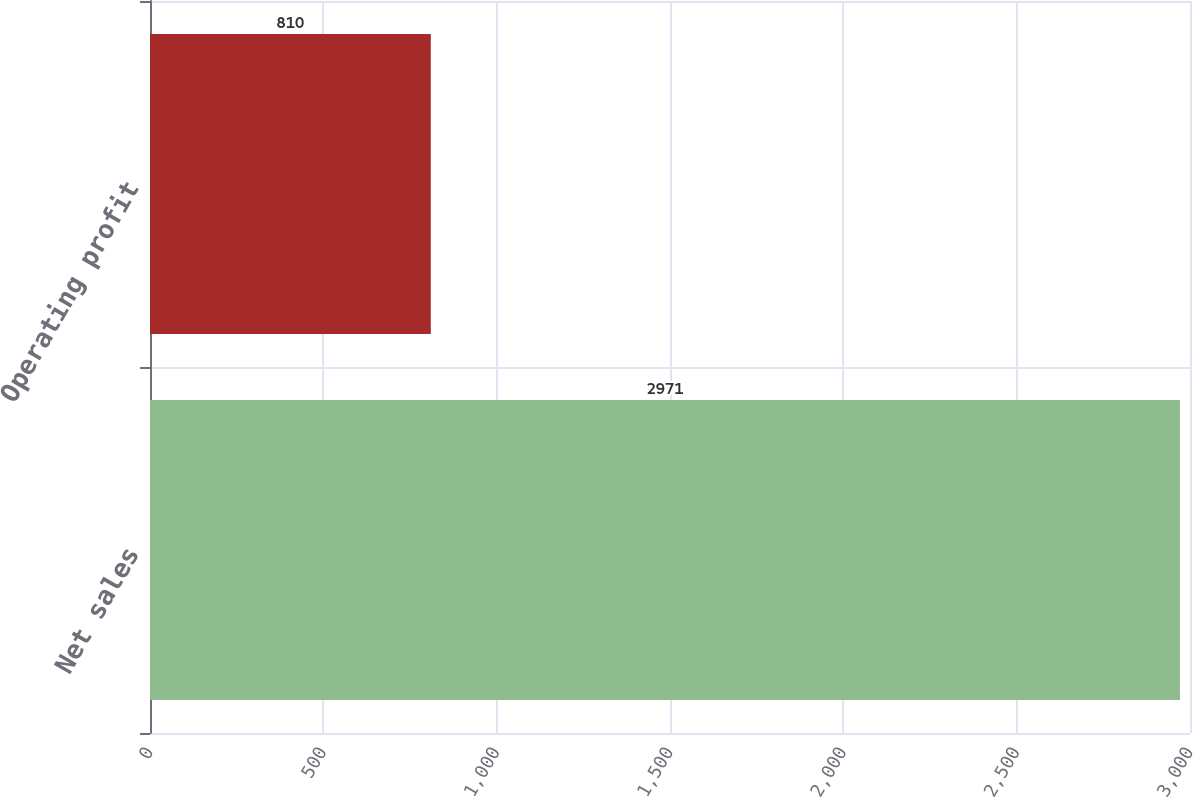Convert chart to OTSL. <chart><loc_0><loc_0><loc_500><loc_500><bar_chart><fcel>Net sales<fcel>Operating profit<nl><fcel>2971<fcel>810<nl></chart> 